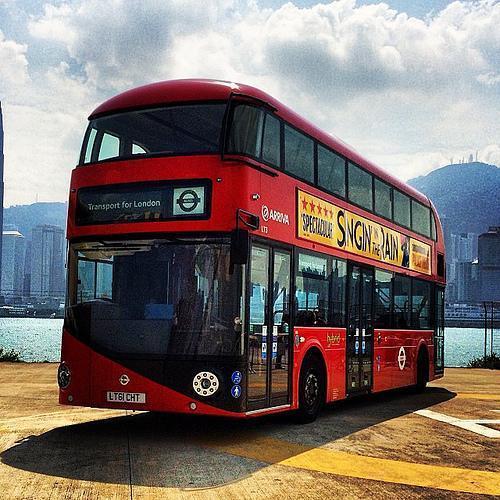How many vehicles are shown?
Give a very brief answer. 1. 